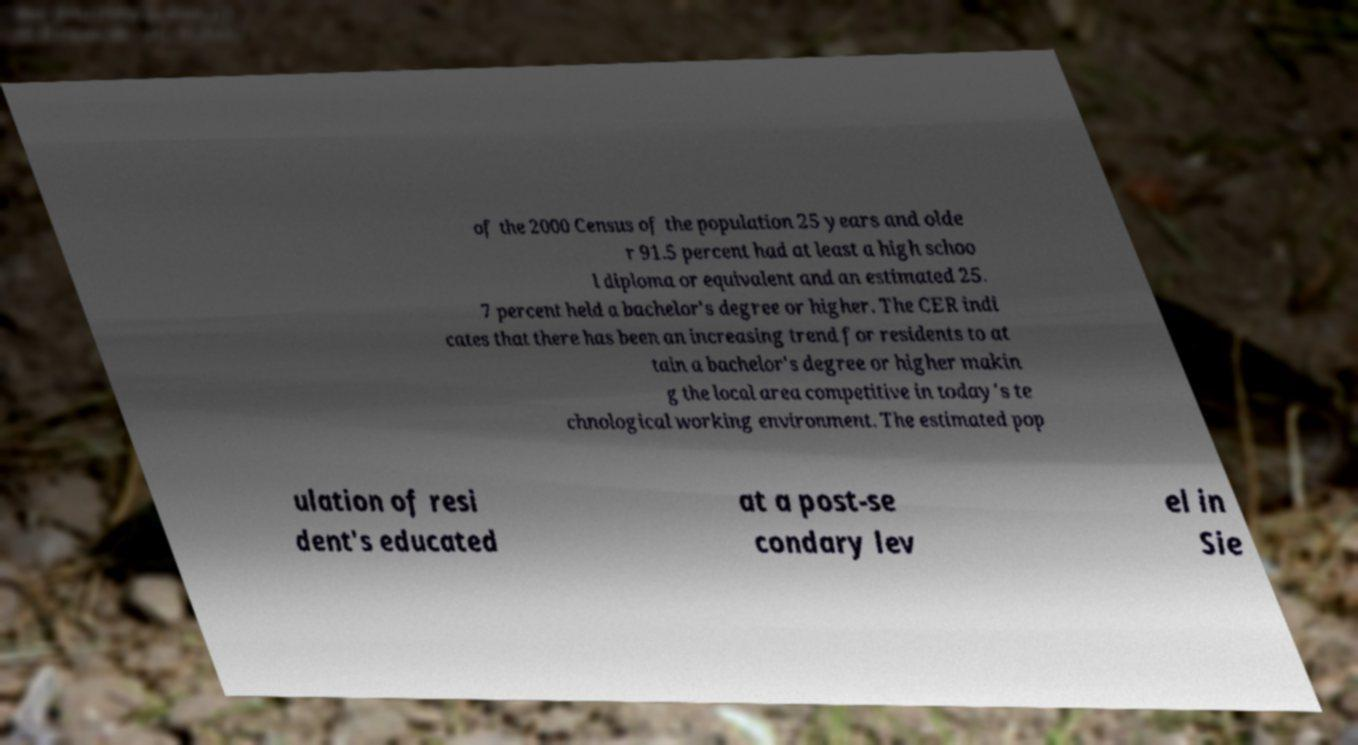Could you extract and type out the text from this image? of the 2000 Census of the population 25 years and olde r 91.5 percent had at least a high schoo l diploma or equivalent and an estimated 25. 7 percent held a bachelor's degree or higher. The CER indi cates that there has been an increasing trend for residents to at tain a bachelor's degree or higher makin g the local area competitive in today's te chnological working environment. The estimated pop ulation of resi dent's educated at a post-se condary lev el in Sie 